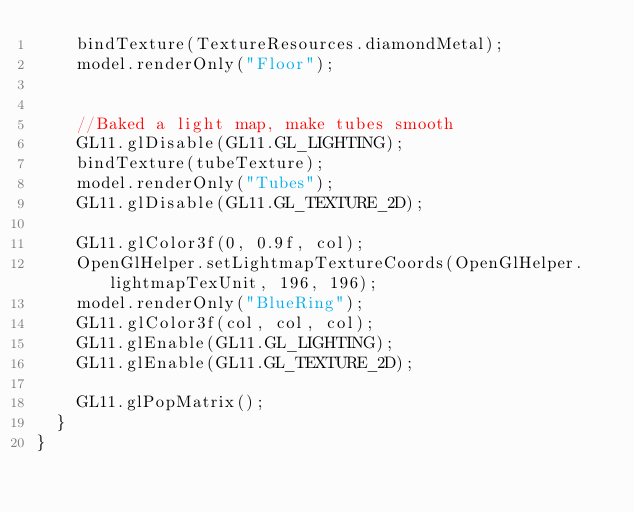<code> <loc_0><loc_0><loc_500><loc_500><_Java_>		bindTexture(TextureResources.diamondMetal);
		model.renderOnly("Floor");
		
		
		//Baked a light map, make tubes smooth
		GL11.glDisable(GL11.GL_LIGHTING);
		bindTexture(tubeTexture);
		model.renderOnly("Tubes");
		GL11.glDisable(GL11.GL_TEXTURE_2D);
		
		GL11.glColor3f(0, 0.9f, col);
		OpenGlHelper.setLightmapTextureCoords(OpenGlHelper.lightmapTexUnit, 196, 196);
		model.renderOnly("BlueRing");
		GL11.glColor3f(col, col, col);
		GL11.glEnable(GL11.GL_LIGHTING);
		GL11.glEnable(GL11.GL_TEXTURE_2D);
		
		GL11.glPopMatrix();
	}
}
</code> 